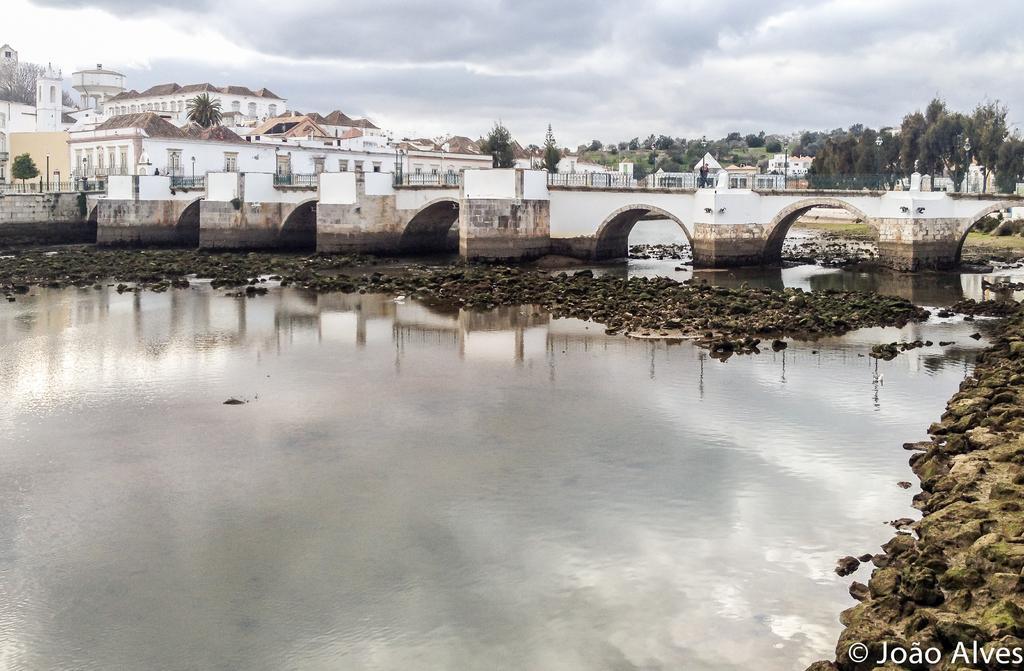How would you summarize this image in a sentence or two? In the foreground of the picture there are stones and water. In the center of the picture there is a bridge. In the background towards right there are trees and building. The background towards left there are palm trees, plants and buildings. Sky is cloudy. 